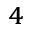Convert formula to latex. <formula><loc_0><loc_0><loc_500><loc_500>^ { 4 }</formula> 